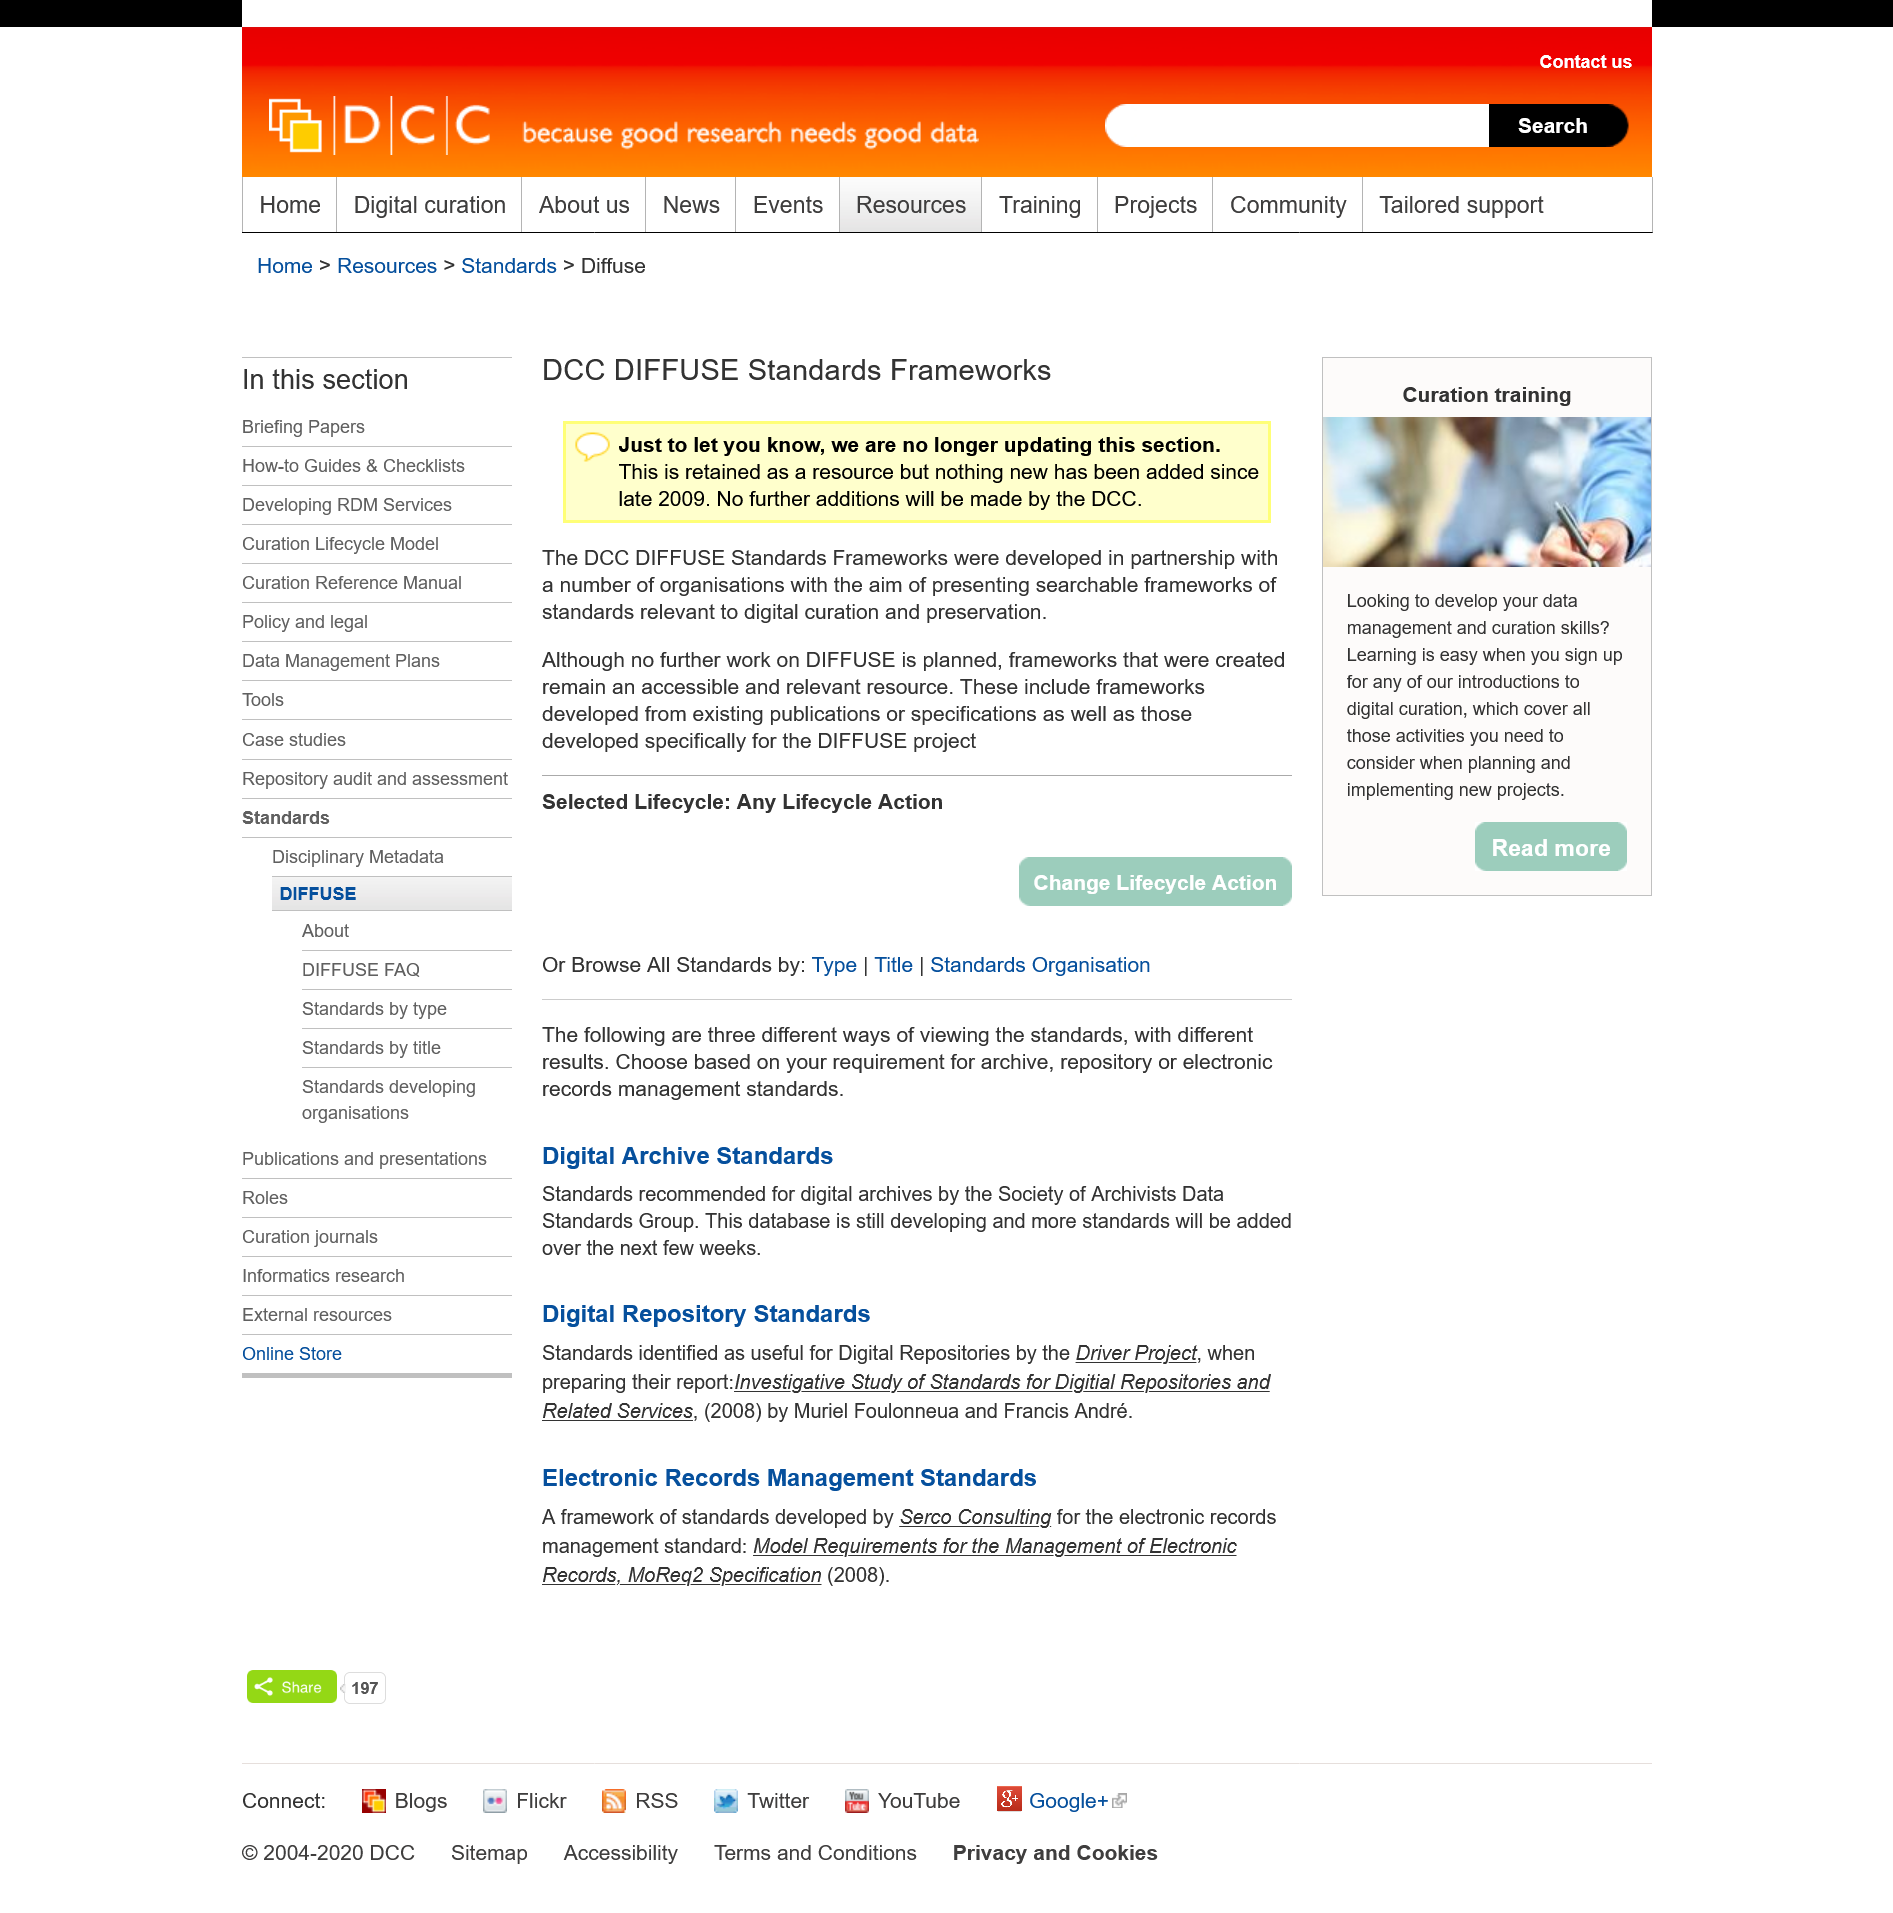Indicate a few pertinent items in this graphic. The DCC Diffuse Standards Frameworks have not added any new resources since late 2009. The DCC DIFFUSE Standards Framework was created by a collaboration of various organisations. 